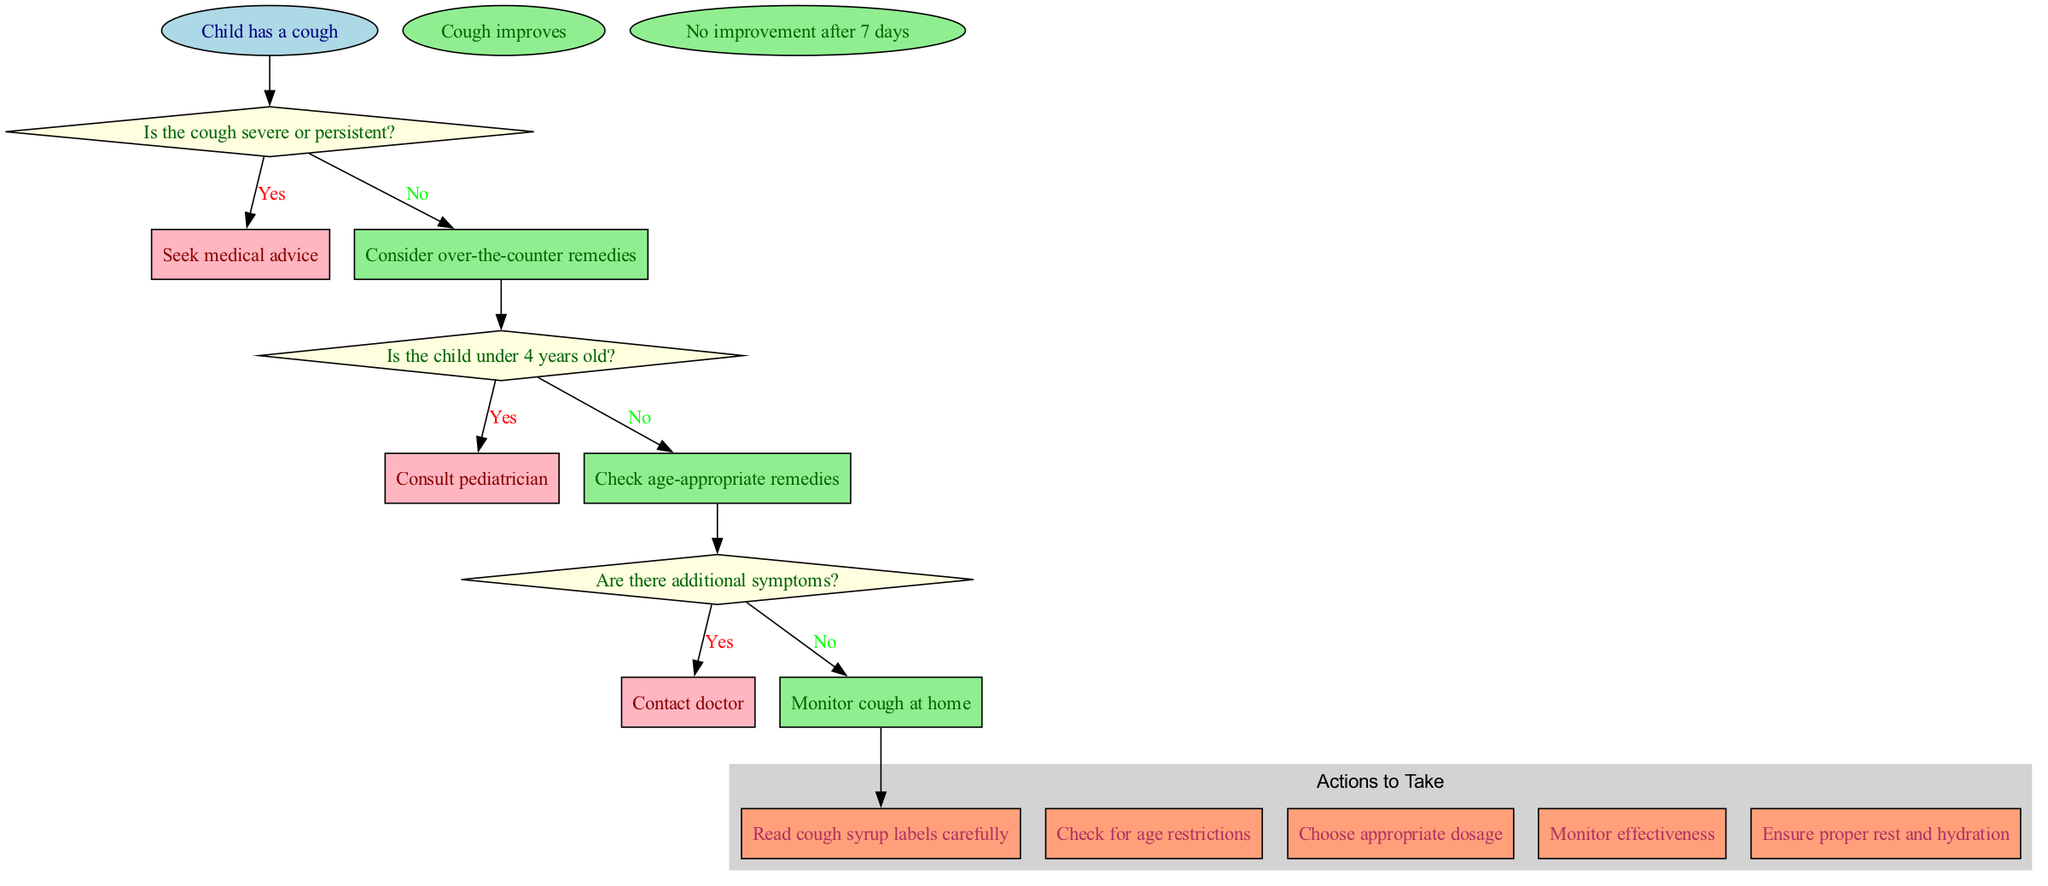What is the first action to take if the cough is not severe or persistent? If the cough is not severe or persistent, the diagram indicates that the next step is to consider over-the-counter remedies. Therefore, this is the first action.
Answer: Consider over-the-counter remedies How many decision nodes are present in the diagram? The diagram shows three decision nodes based on the questions asked about the child's cough severity, age, and additional symptoms. Counting these reveals that there are three decision nodes.
Answer: 3 What should you do if the child is under 4 years old? According to the diagram, if the child is under 4 years old, you should consult a pediatrician. This is the action to take in this scenario.
Answer: Consult pediatrician What indicates that you should seek medical advice immediately? The diagram states that if the cough is severe or persistent, the action is to seek medical advice. This condition explicitly leads to that decision.
Answer: Seek medical advice What happens if there are additional symptoms alongside the cough? If there are additional symptoms present, the flowchart directs you to contact the doctor as the next action. This highlights the seriousness of combining symptoms.
Answer: Contact doctor What is indicated after monitoring the cough at home? After monitoring the cough at home, the diagram leads to the end conditions—either you may see improvement or there is no improvement after 7 days, both of which summarize possible outcomes.
Answer: Cough improves, No improvement after 7 days 